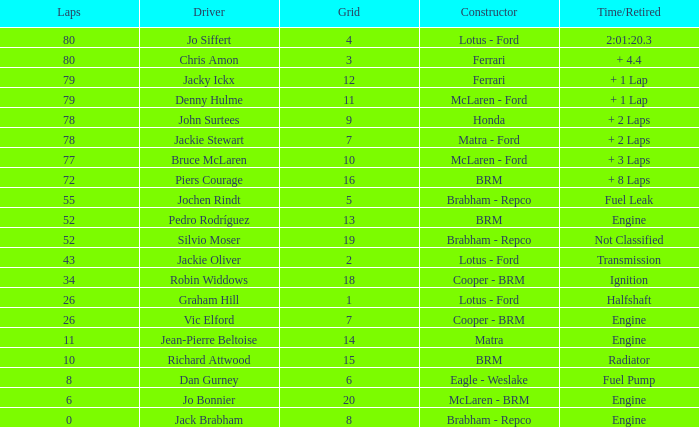When the driver richard attwood has a maker of brm, what is the total of laps? 10.0. 